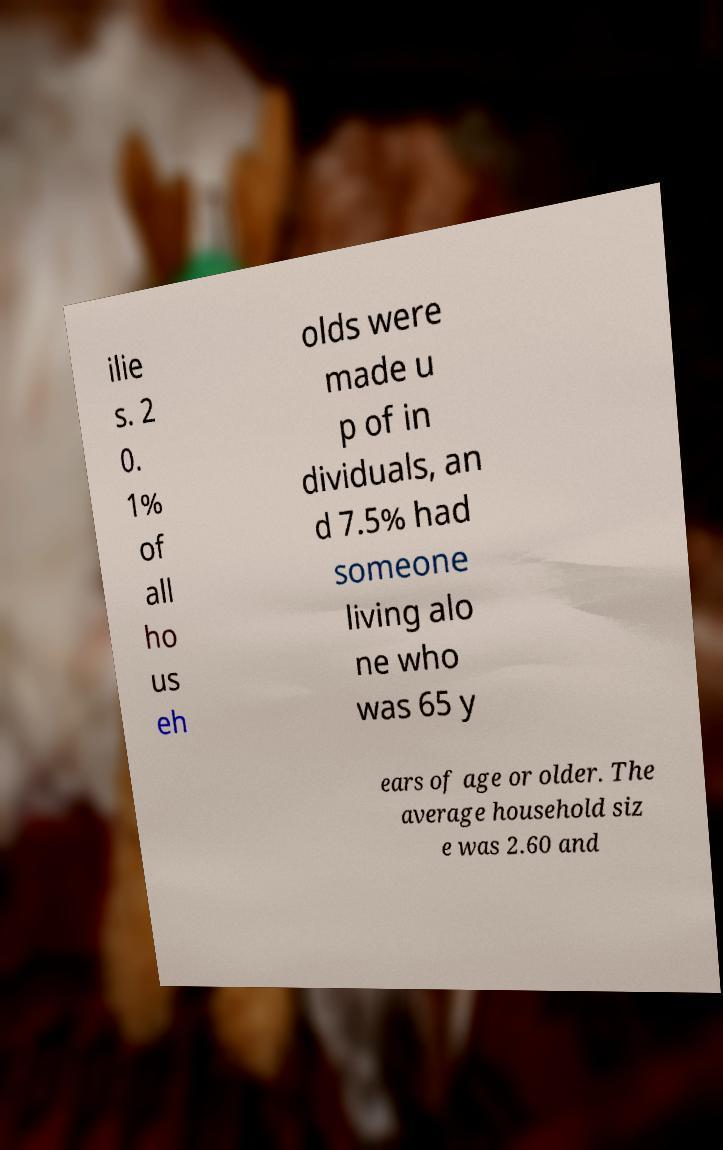Can you read and provide the text displayed in the image?This photo seems to have some interesting text. Can you extract and type it out for me? ilie s. 2 0. 1% of all ho us eh olds were made u p of in dividuals, an d 7.5% had someone living alo ne who was 65 y ears of age or older. The average household siz e was 2.60 and 